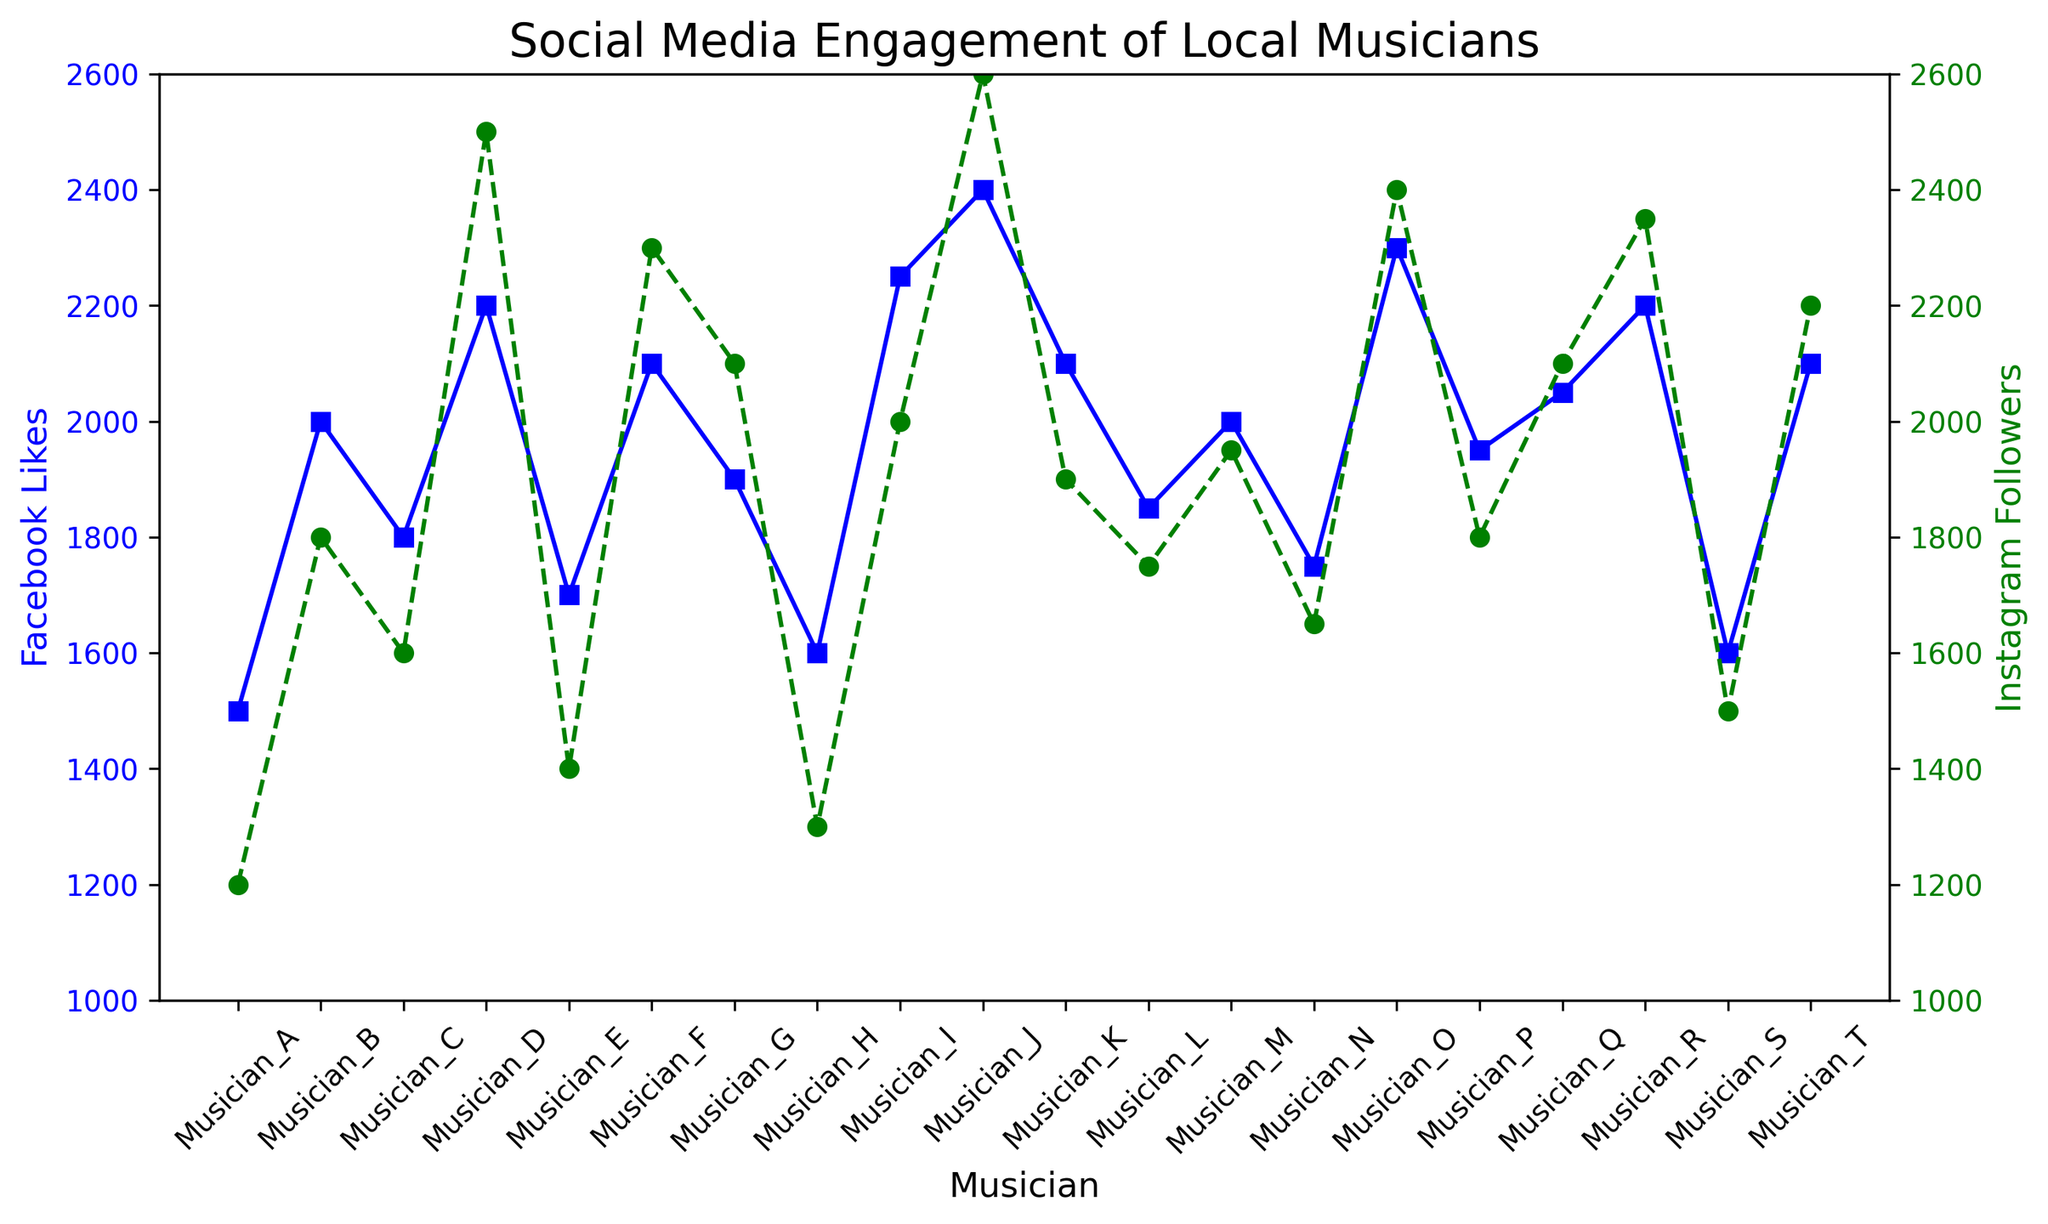Which musician has the most Instagram followers? The green markers represent Instagram followers. Find the musician with the highest point on the green line. This corresponds to Musician_J with 2600 followers.
Answer: Musician_J Which musician has a higher count of Facebook likes than Instagram followers? Compare the blue and green lines for each musician. Musicians B, E, H, K, M, and S have more Facebook likes than Instagram followers.
Answer: Musicians B, E, H, K, M, S What is the average number of Instagram followers among the musicians? Sum the Instagram followers (1200+1800+1600+2500+1400+2300+2100+1300+2000+2600+1900+1750+1950+1650+2400+1800+2100+2350+1500+2200 = 39850), then divide by the number of musicians (20).
Answer: 1992.5 Which musicians have equal Facebook likes and Instagram followers? Check where the blue and green lines meet at the same value. There are no such intersections in the chart.
Answer: None Which musician shows the greatest difference between Facebook likes and Instagram followers? Calculate the differences for each musician and identify the maximum: Musician_D (2200-2500=-300), Musician_J (2400-2600=-200), and so forth. The greatest absolute difference is for Musician_D.
Answer: Musician_D Are there more musicians with over 2000 Facebook likes or over 2000 Instagram followers? Count the musicians with over 2000 likes (B, D, F, G, I, J, K, O, Q, R, T = 11) and over 2000 followers (D, F, G, I, J, O, Q, R, T = 9)
Answer: Facebook likes Between Musicians A and B, who has a higher social media engagement on average? Calculate the average for both: Musician_A (1500+1200=2700, avg=1350) and Musician_B (2000+1800=3800, avg=1900). Compare the averages.
Answer: Musician_B Which musician has the least Facebook likes? The lowest point of the blue markers corresponds to Musician_A and Musician_H with 1500.
Answer: Musician_A and Musician_H 